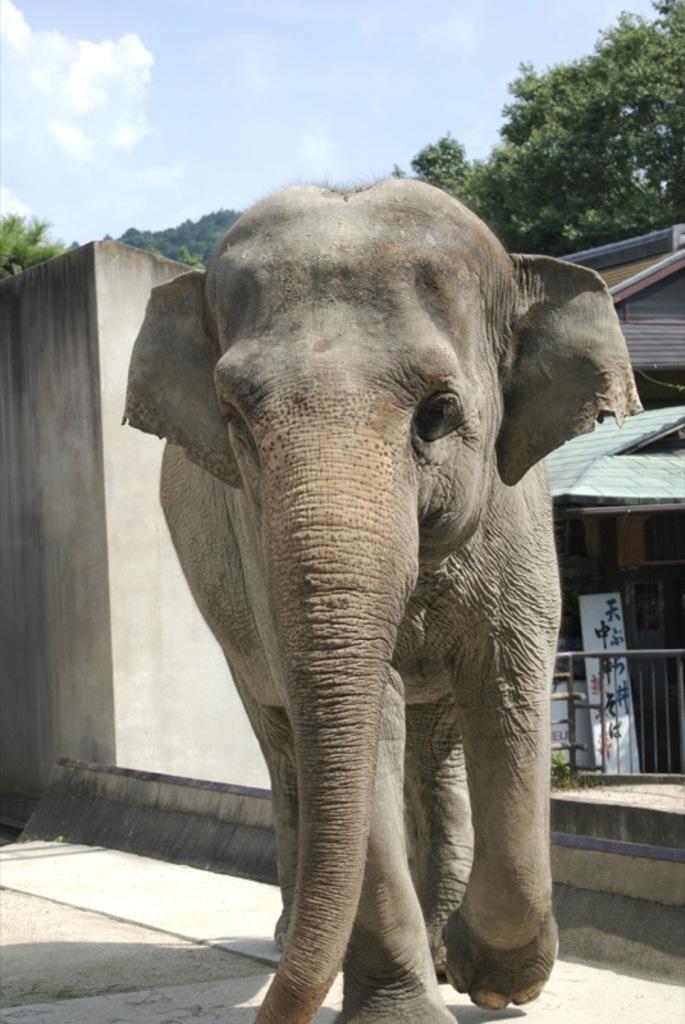Describe this image in one or two sentences. In this image I can see an elephant which is in brown and grey color. To the side of an elephant I can see the railing and the board. In the background I can see the wall, house, many trees, clouds and the sky. 